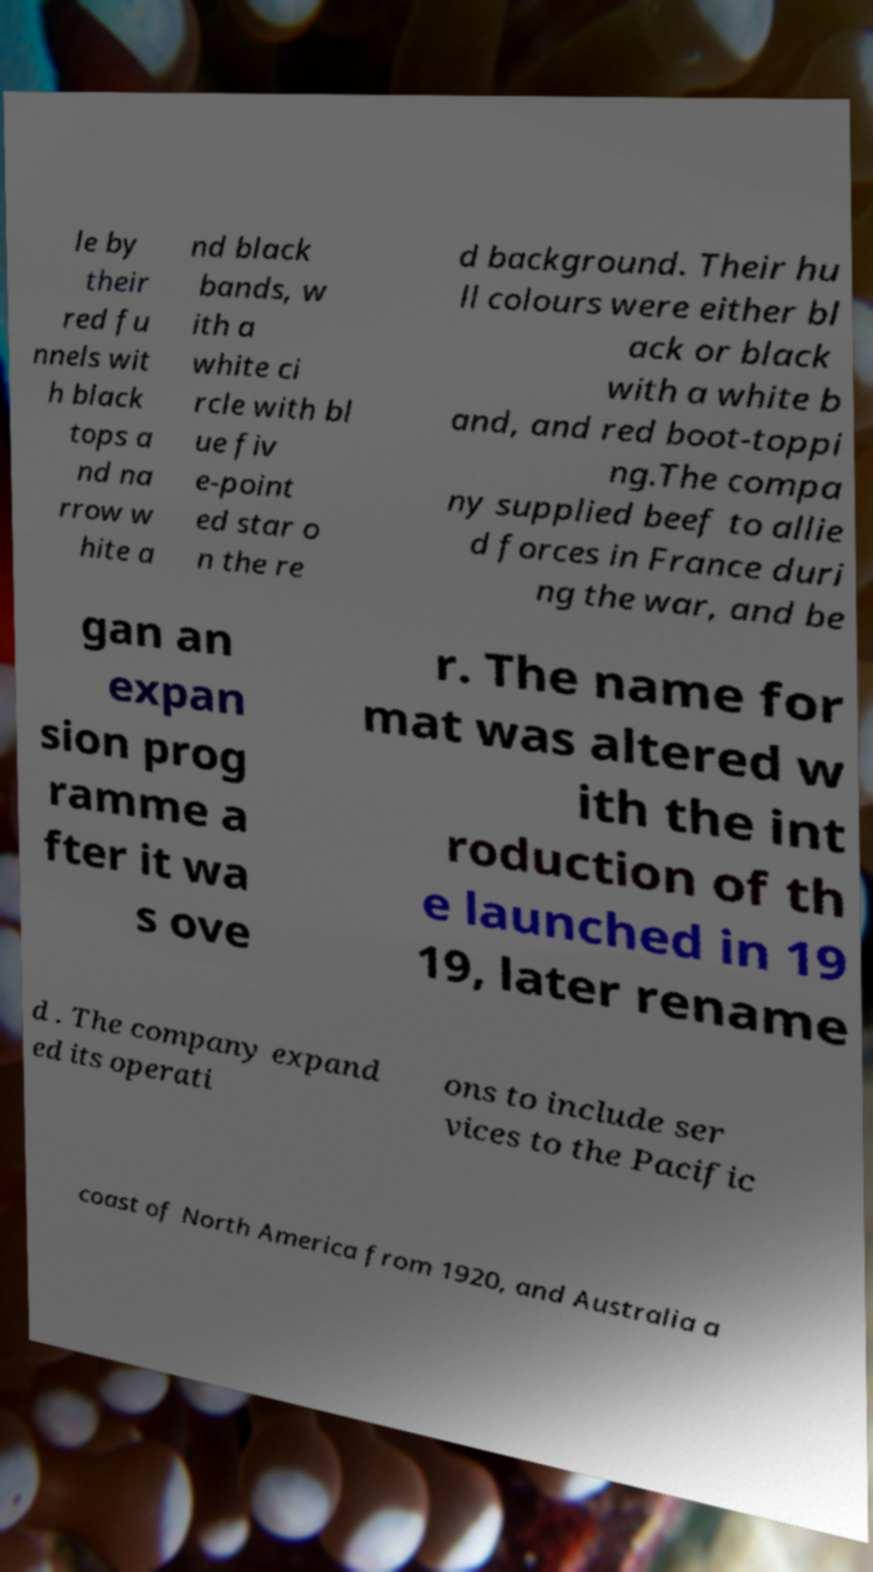Please identify and transcribe the text found in this image. le by their red fu nnels wit h black tops a nd na rrow w hite a nd black bands, w ith a white ci rcle with bl ue fiv e-point ed star o n the re d background. Their hu ll colours were either bl ack or black with a white b and, and red boot-toppi ng.The compa ny supplied beef to allie d forces in France duri ng the war, and be gan an expan sion prog ramme a fter it wa s ove r. The name for mat was altered w ith the int roduction of th e launched in 19 19, later rename d . The company expand ed its operati ons to include ser vices to the Pacific coast of North America from 1920, and Australia a 